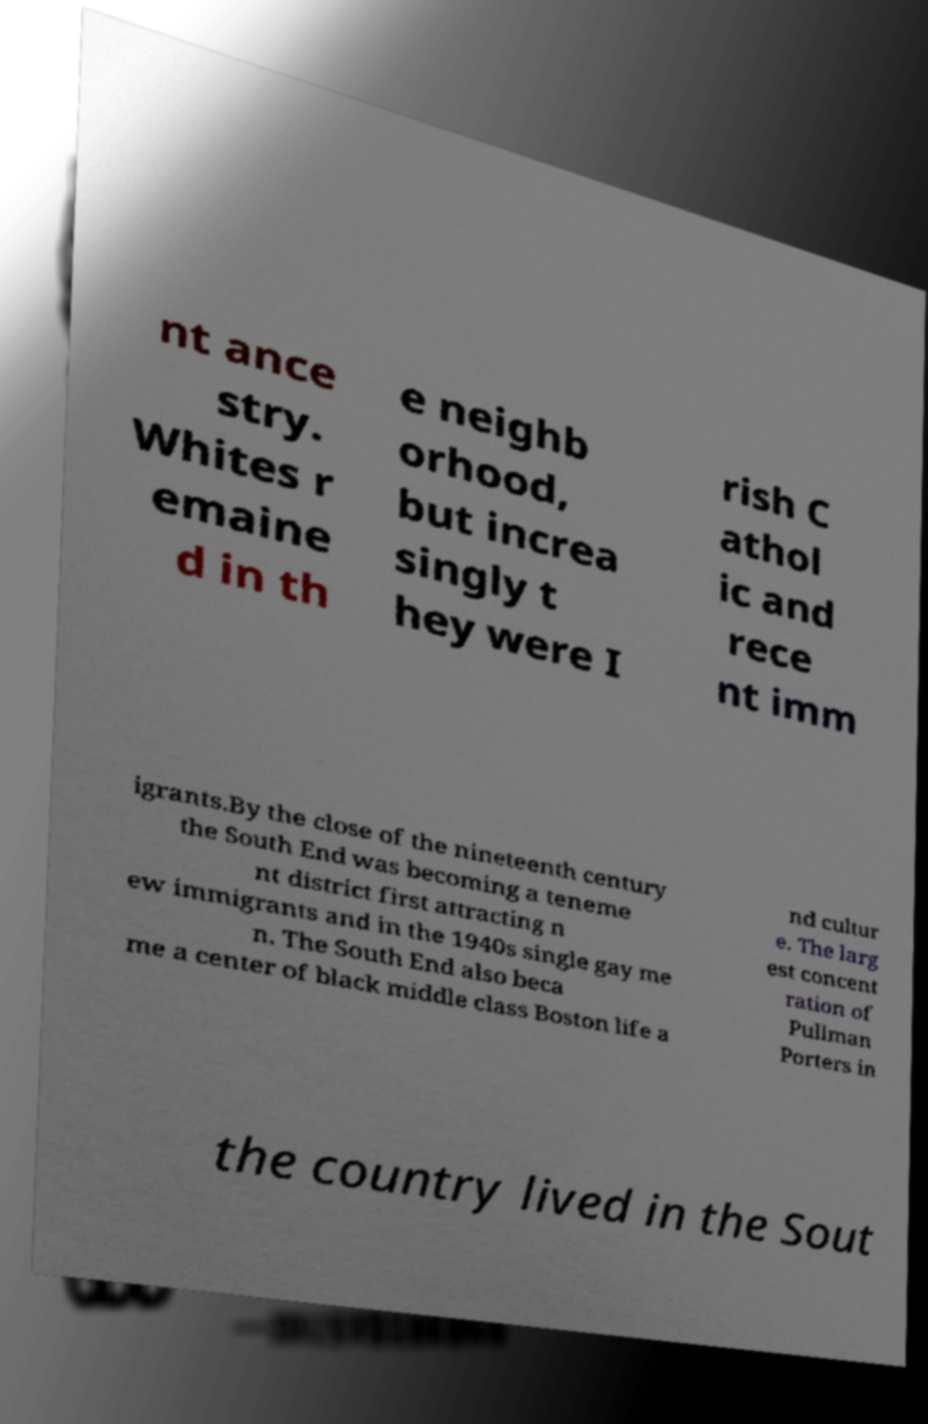Please identify and transcribe the text found in this image. nt ance stry. Whites r emaine d in th e neighb orhood, but increa singly t hey were I rish C athol ic and rece nt imm igrants.By the close of the nineteenth century the South End was becoming a teneme nt district first attracting n ew immigrants and in the 1940s single gay me n. The South End also beca me a center of black middle class Boston life a nd cultur e. The larg est concent ration of Pullman Porters in the country lived in the Sout 